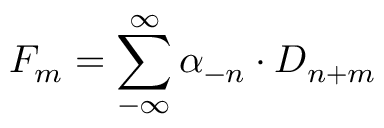<formula> <loc_0><loc_0><loc_500><loc_500>F _ { m } = \sum _ { - \infty } ^ { \infty } \alpha _ { - n } \cdot D _ { n + m }</formula> 